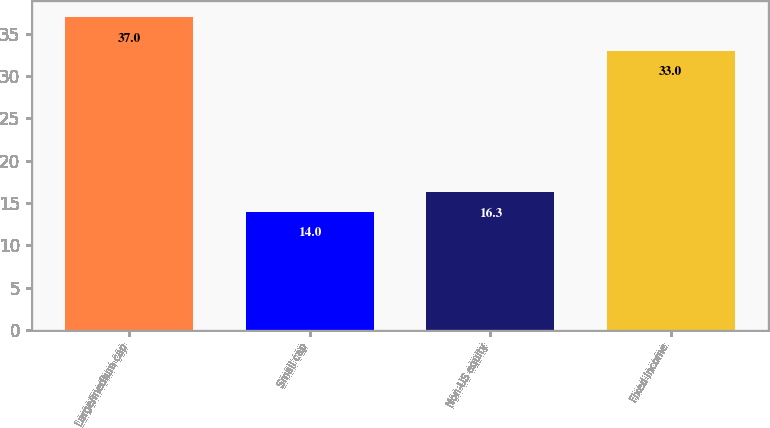Convert chart to OTSL. <chart><loc_0><loc_0><loc_500><loc_500><bar_chart><fcel>Large/medium cap<fcel>Small cap<fcel>Non-US equity<fcel>Fixed income<nl><fcel>37<fcel>14<fcel>16.3<fcel>33<nl></chart> 